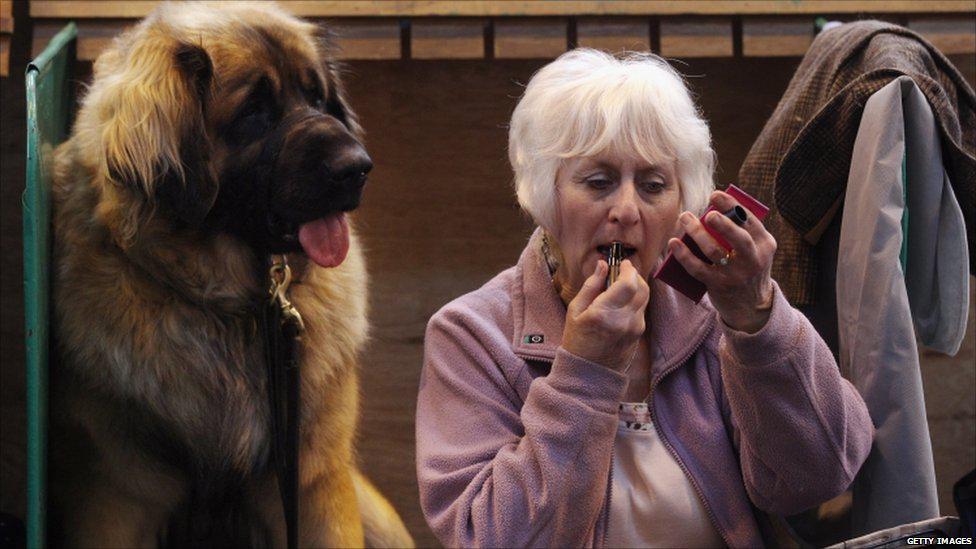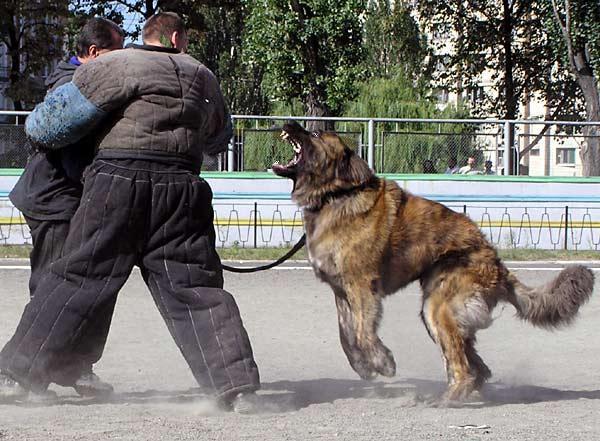The first image is the image on the left, the second image is the image on the right. Analyze the images presented: Is the assertion "At least one person is petting a dog." valid? Answer yes or no. No. The first image is the image on the left, the second image is the image on the right. For the images shown, is this caption "There are exactly two dogs in the right image." true? Answer yes or no. No. 